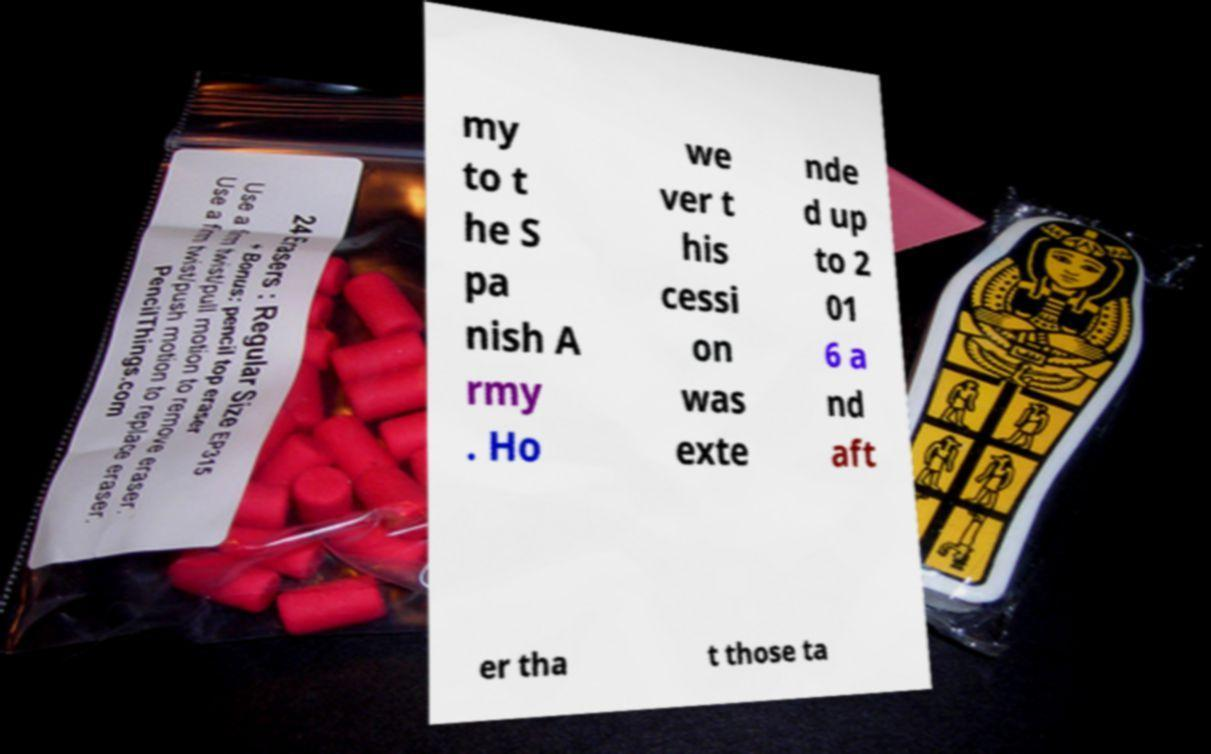Can you accurately transcribe the text from the provided image for me? my to t he S pa nish A rmy . Ho we ver t his cessi on was exte nde d up to 2 01 6 a nd aft er tha t those ta 